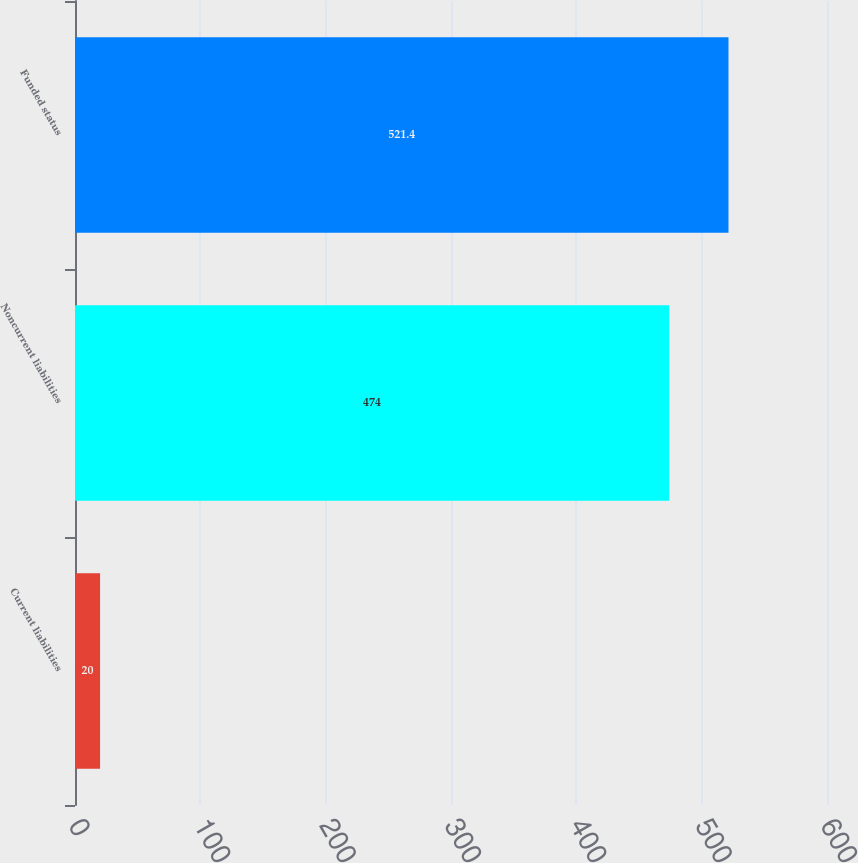Convert chart. <chart><loc_0><loc_0><loc_500><loc_500><bar_chart><fcel>Current liabilities<fcel>Noncurrent liabilities<fcel>Funded status<nl><fcel>20<fcel>474<fcel>521.4<nl></chart> 